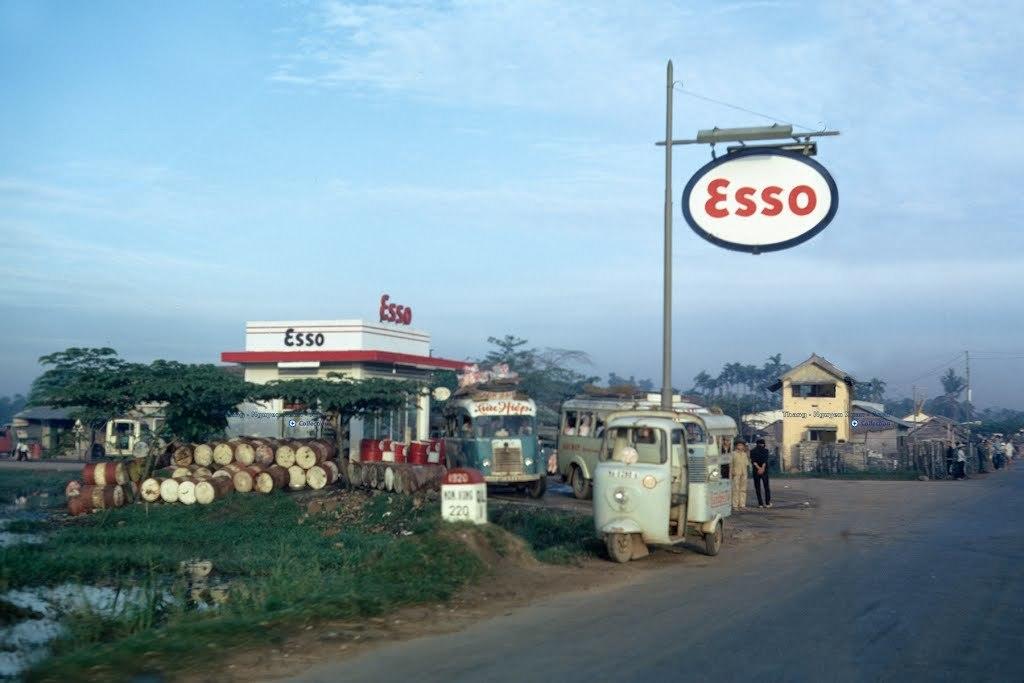Please provide a concise description of this image. In the bottom right corner of the image there is road. In the bottom left corner of the image there is grass and mud. In the middle of the image there are some vehicles and houses and poles and sign boards. Behind the houses there are some trees. At the top of the image there are some clouds and sky. Behind the vehicles few people are standing. 